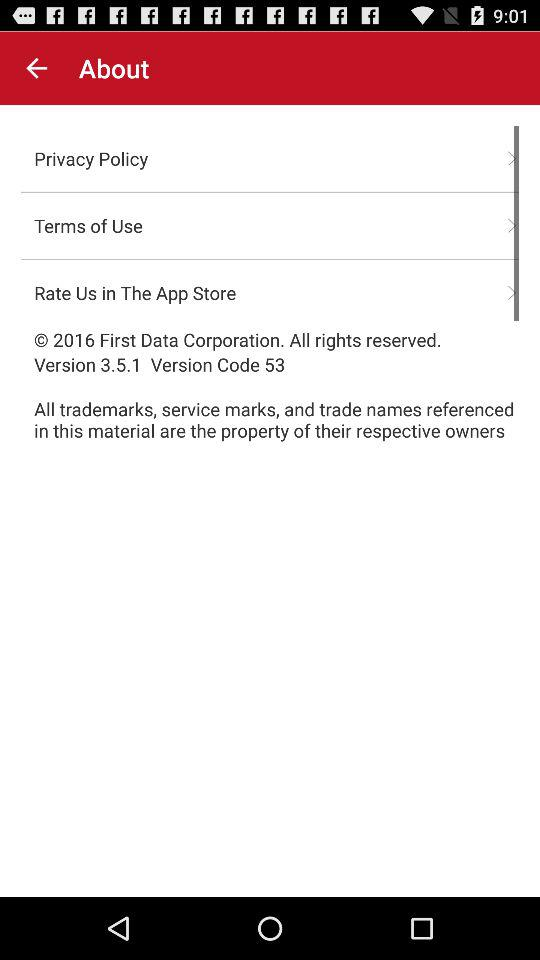What is the version code? The version code is 53. 